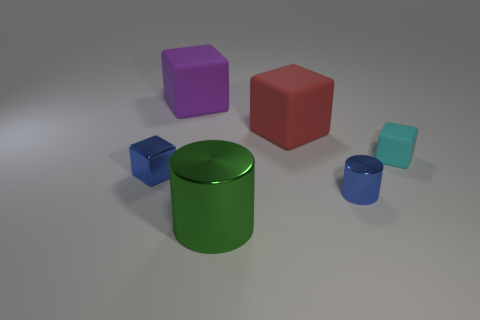What number of objects are either big green things or small blue things that are to the right of the large purple block?
Keep it short and to the point. 2. The other tiny cylinder that is the same material as the green cylinder is what color?
Give a very brief answer. Blue. What number of objects are green rubber objects or tiny objects?
Give a very brief answer. 3. There is a matte cube that is the same size as the blue cylinder; what color is it?
Give a very brief answer. Cyan. How many things are big matte cubes in front of the large purple object or matte blocks?
Give a very brief answer. 3. How many other objects are the same size as the blue shiny cube?
Keep it short and to the point. 2. There is a metallic cube behind the tiny blue cylinder; how big is it?
Keep it short and to the point. Small. The purple thing that is the same material as the large red cube is what shape?
Give a very brief answer. Cube. Is there any other thing that is the same color as the small rubber thing?
Give a very brief answer. No. What color is the small metallic object that is in front of the block that is left of the big purple rubber object?
Your response must be concise. Blue. 